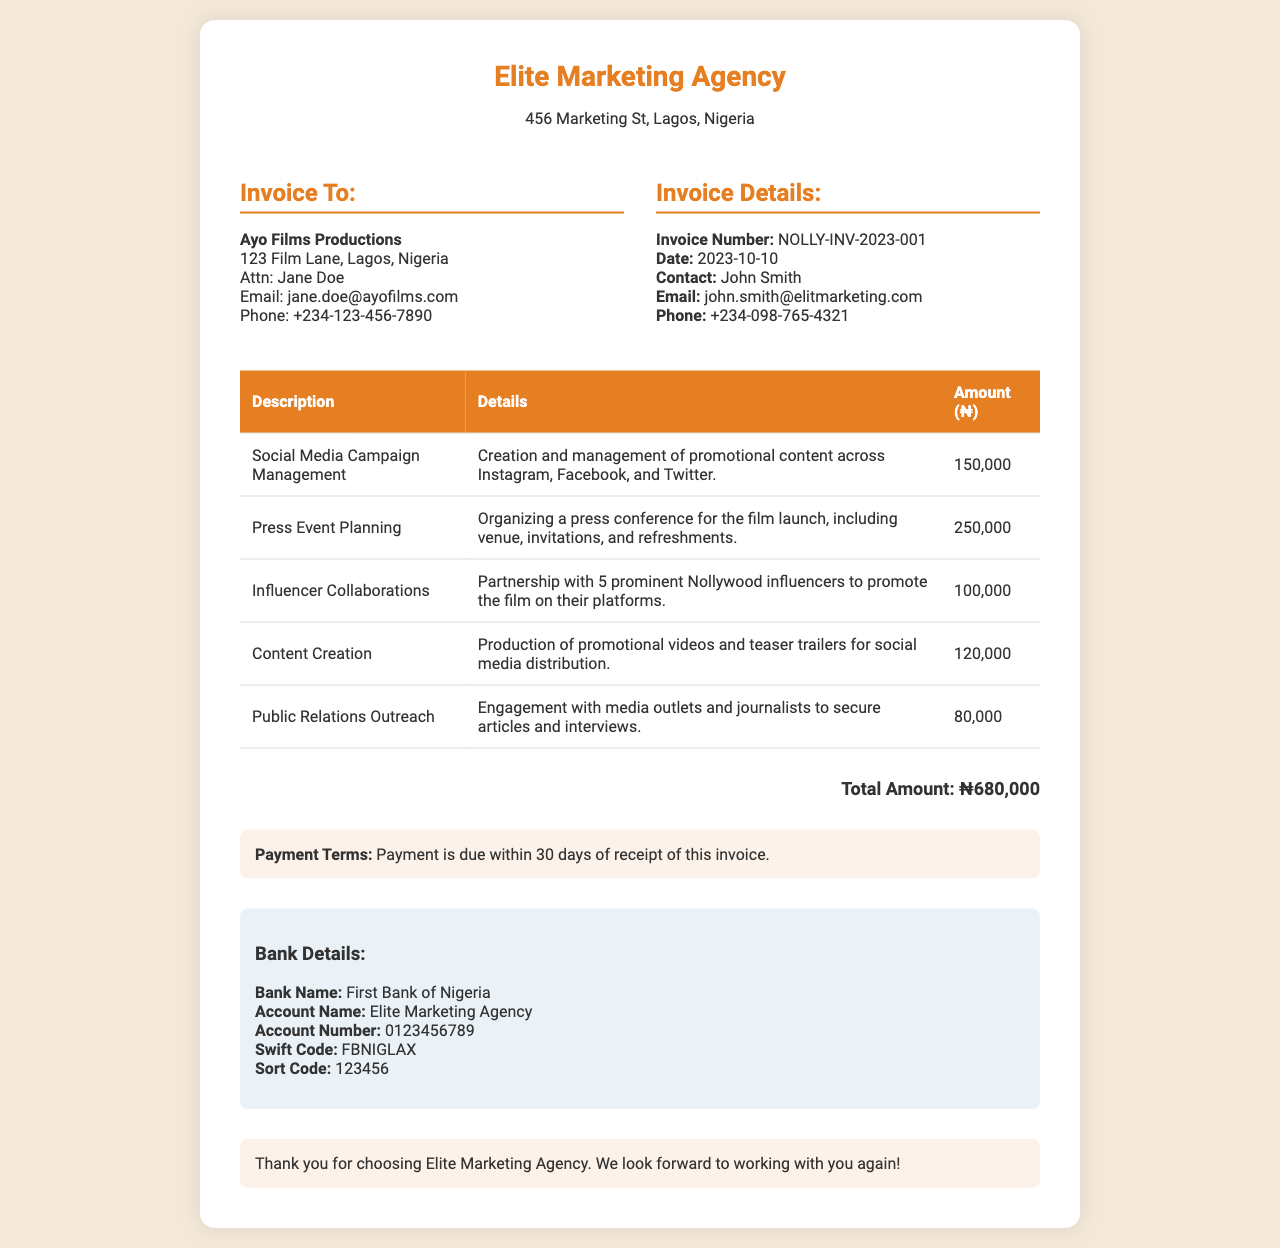What is the invoice number? The invoice number is noted in the document under "Invoice Details," identifying it as the unique reference for this invoice.
Answer: NOLLY-INV-2023-001 What is the total amount due? The total amount due is calculated by adding all individual service charges presented in the document.
Answer: ₦680,000 Who is the primary contact person for the talent agency? The primary contact person's name is provided in the "Invoice Details" section for communication regarding this invoice.
Answer: John Smith What date was the invoice issued? The date of issuance is indicated in the "Invoice Details" section, specifically labeled as the date of the invoice.
Answer: 2023-10-10 What is included in the social media campaign management? The details under the specific service item in the table outline the services included in the social media campaign management.
Answer: Creation and management of promotional content across Instagram, Facebook, and Twitter How many influencers were collaborated with for the promotion? The details specify the number of influencers involved in promoting the film, relevant to the influencer collaboration line item.
Answer: 5 What payment terms are specified in the invoice? The payment terms outline the conditions under which the payment should be made as mentioned in a distinct notes section.
Answer: Payment is due within 30 days of receipt of this invoice What is the account name for the bank details? The account name is found in the bank details section, providing the exact title for financial transactions.
Answer: Elite Marketing Agency What kind of event was planned according to the invoice? The planning type is specified in the second item of the table, clarifying the nature of the event organized.
Answer: Press conference 